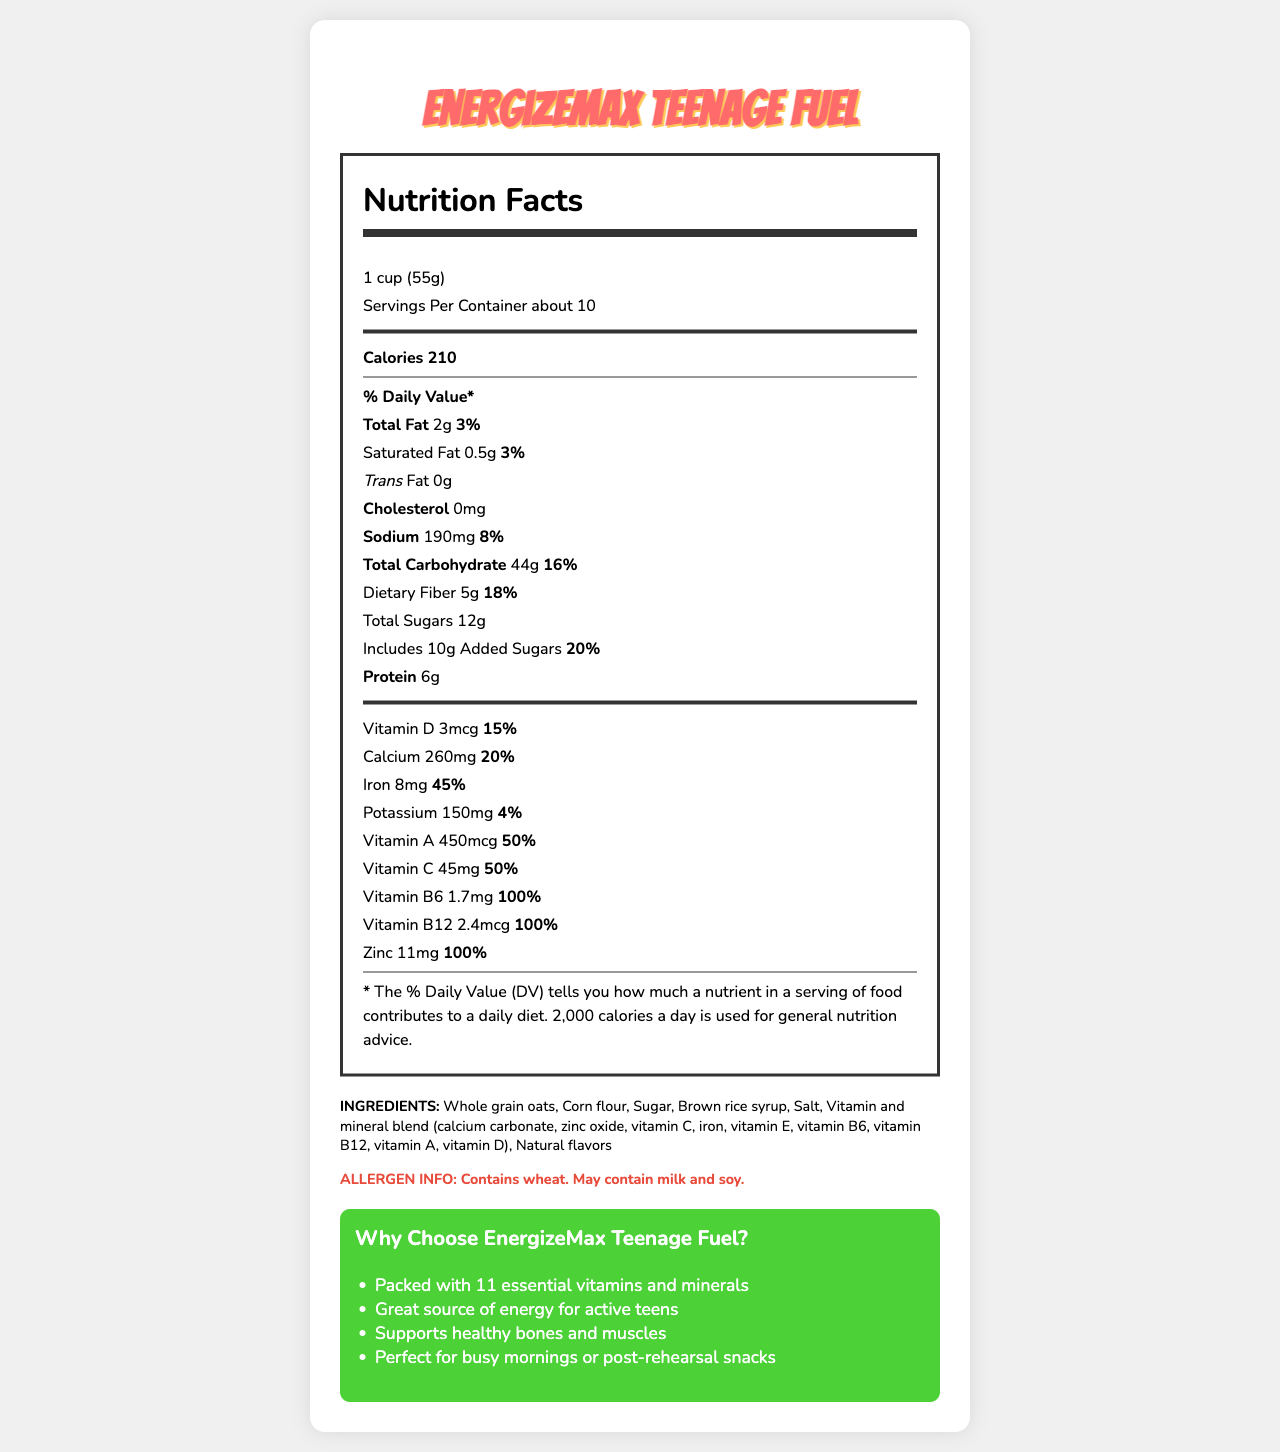What is the serving size for EnergizeMax Teenage Fuel? The serving size is clearly stated in the document as "1 cup (55g)."
Answer: 1 cup (55g) How many calories are in one serving of EnergizeMax Teenage Fuel? The document lists calories per serving as 210.
Answer: 210 How much protein does one serving contain? The document states that one serving contains 6g of protein.
Answer: 6g What percentage of the daily value for iron does one serving provide? The iron content is listed as providing 45% of the daily value.
Answer: 45% What are the main vitamins included in EnergizeMax Teenage Fuel? These vitamins are listed in the nutrition section with their respective amounts and daily values.
Answer: Vitamin D, Calcium, Iron, Vitamin A, Vitamin C, Vitamin B6, Vitamin B12, Zinc Does this cereal contain any trans fat? The document indicates 0g of trans fat in one serving.
Answer: No What are the allergens mentioned for EnergizeMax Teenage Fuel? A. Nuts B. Wheat C. Soy D. Eggs The allergens listed are wheat and a note that the product may contain milk and soy.
Answer: B, C What percentage of the daily value of Vitamin C does one serving provide? A. 25% B. 50% C. 75% D. 100% The document says that the food has 45mg of Vitamin C, which is 50% of the daily value.
Answer: B Which ingredient is NOT listed for EnergizeMax Teenage Fuel? 1. Whole grain oats 2. Sugar 3. Skim milk 4. Corn flour Skim milk is not listed in the ingredients, while the others are.
Answer: 3 Is there any sodium in this cereal? The document states that one serving contains 190mg of sodium.
Answer: Yes Summarize the main idea of the document. The summary describes the overall content of the document, its purpose, and the target audience.
Answer: The document provides detailed nutrition facts about EnergizeMax Teenage Fuel, a breakfast cereal targeted at active teenagers. It includes information about serving size, calories, vitamins, minerals, and ingredients. The cereal is marketed as a nutritious option for busy or active teens. What is the exact percentage of the daily value of total carbohydrates in one serving? The document specifies that the total carbohydrate content per serving is 44g, which is 16% of the daily value.
Answer: 16% What are the natural flavors in EnergizeMax Teenage Fuel? The document lists "Natural flavors" as an ingredient but does not specify what they are.
Answer: Cannot be determined How many grams of dietary fiber does one serving have? The document lists 5g of dietary fiber per serving.
Answer: 5g Which vitamin provides 100% of the daily value in one serving? A. Vitamin D B. Vitamin A C. Vitamin B12 D. Vitamin C Vitamin B12 provides 100% of the daily value per serving, as indicated in the document.
Answer: C Is EnergizeMax Teenage Fuel a good source of zinc? The document indicates that one serving provides 100% of the daily value for zinc, which makes it a good source.
Answer: Yes 